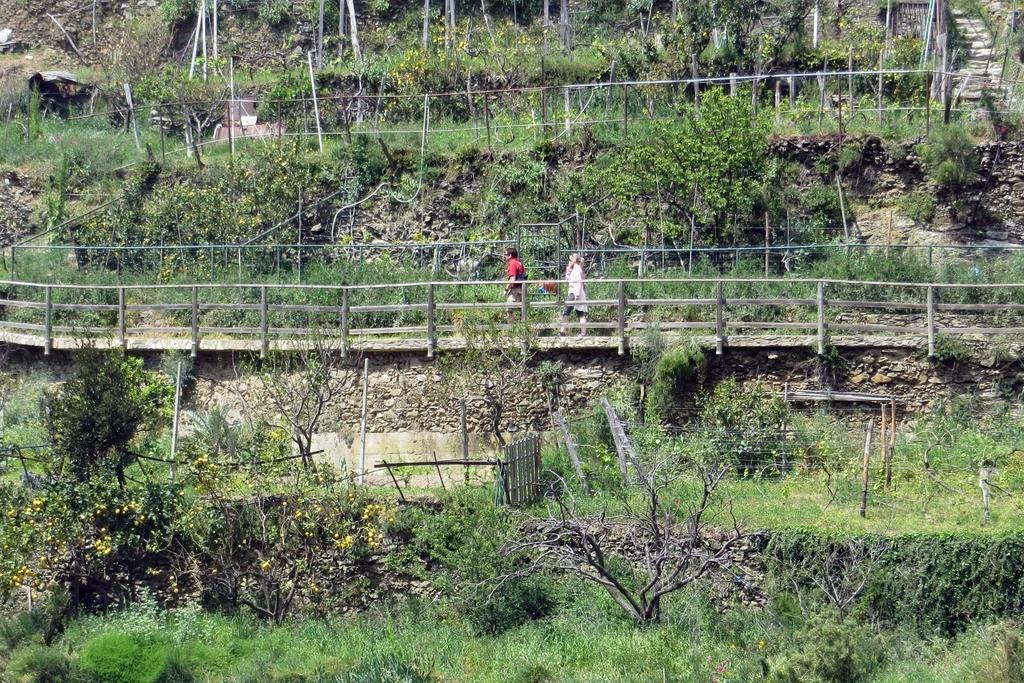Please provide a concise description of this image. In this picture there were two members walking in this path. We can observe a wooden railing. There are plants and trees in this picture. 